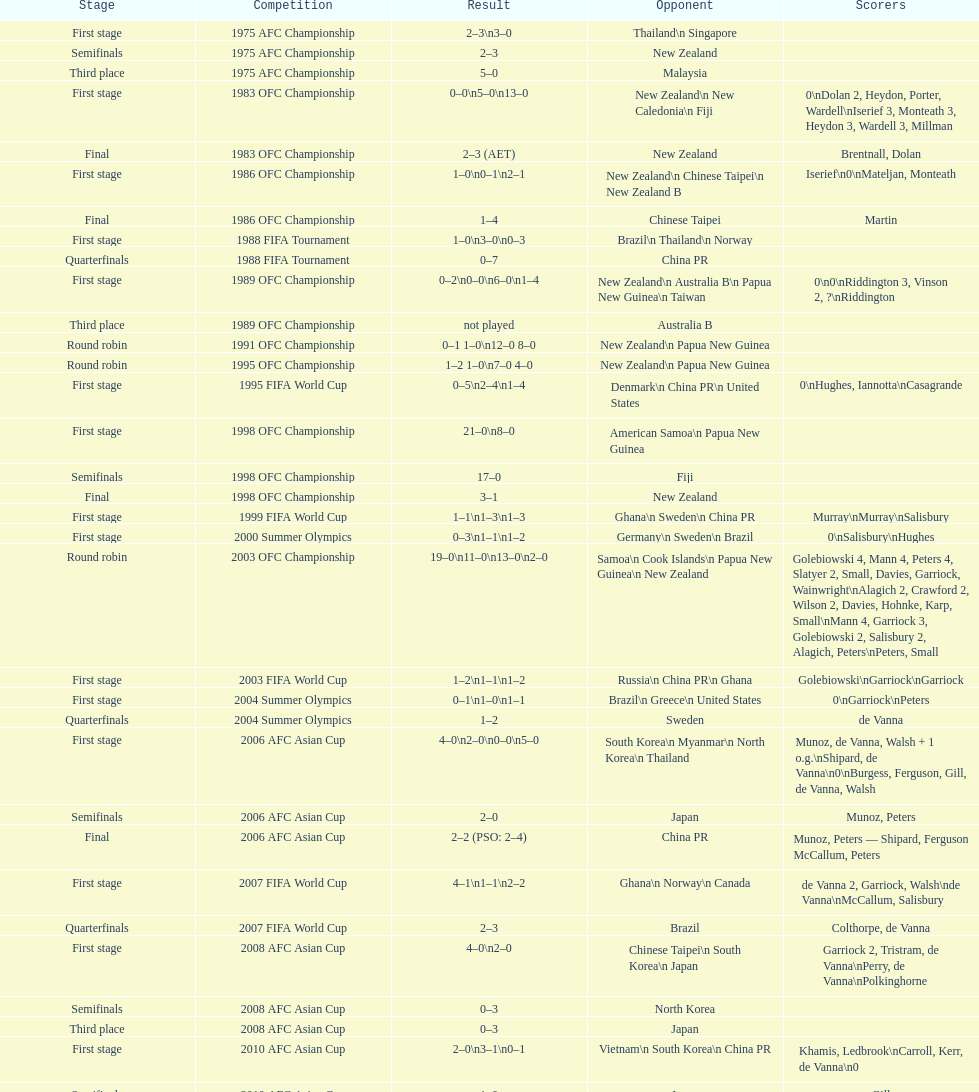What is the total number of competitions? 21. 